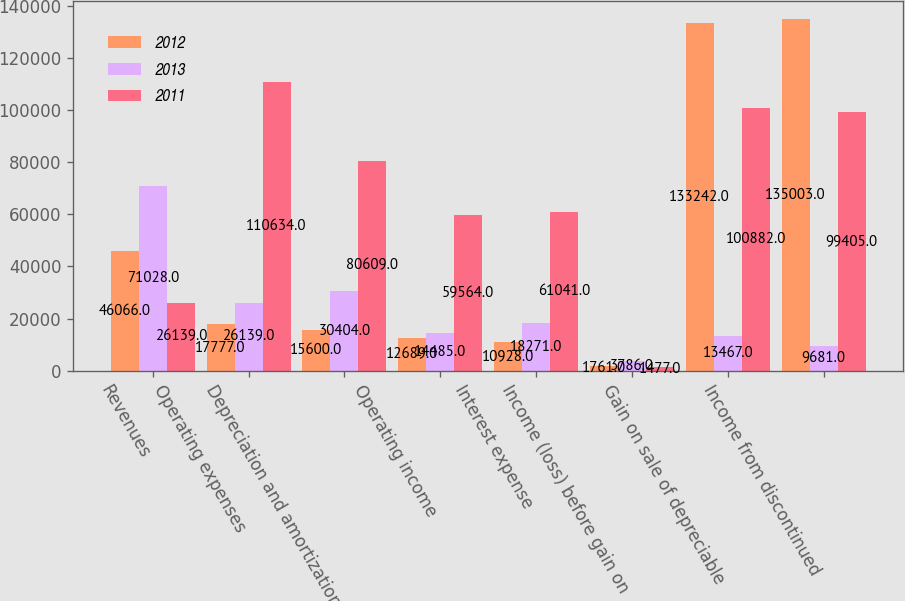Convert chart. <chart><loc_0><loc_0><loc_500><loc_500><stacked_bar_chart><ecel><fcel>Revenues<fcel>Operating expenses<fcel>Depreciation and amortization<fcel>Operating income<fcel>Interest expense<fcel>Income (loss) before gain on<fcel>Gain on sale of depreciable<fcel>Income from discontinued<nl><fcel>2012<fcel>46066<fcel>17777<fcel>15600<fcel>12689<fcel>10928<fcel>1761<fcel>133242<fcel>135003<nl><fcel>2013<fcel>71028<fcel>26139<fcel>30404<fcel>14485<fcel>18271<fcel>3786<fcel>13467<fcel>9681<nl><fcel>2011<fcel>26139<fcel>110634<fcel>80609<fcel>59564<fcel>61041<fcel>1477<fcel>100882<fcel>99405<nl></chart> 